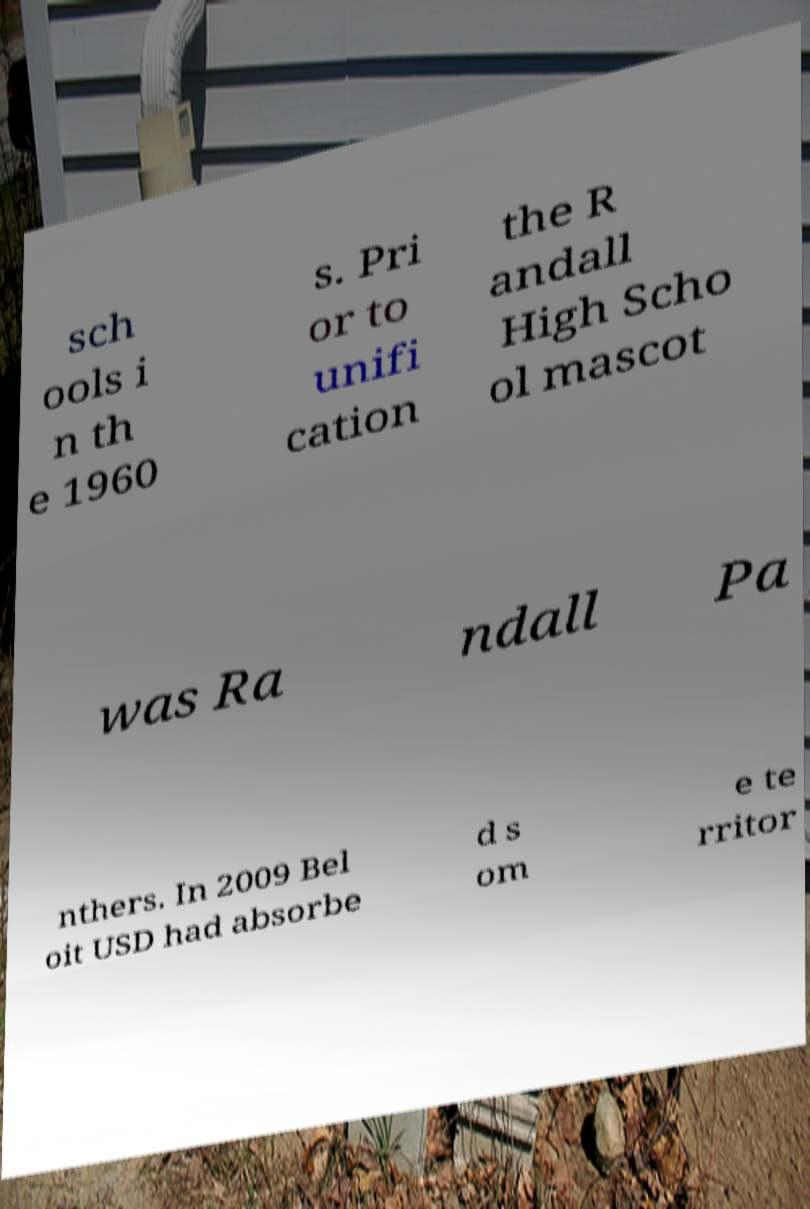Could you extract and type out the text from this image? sch ools i n th e 1960 s. Pri or to unifi cation the R andall High Scho ol mascot was Ra ndall Pa nthers. In 2009 Bel oit USD had absorbe d s om e te rritor 